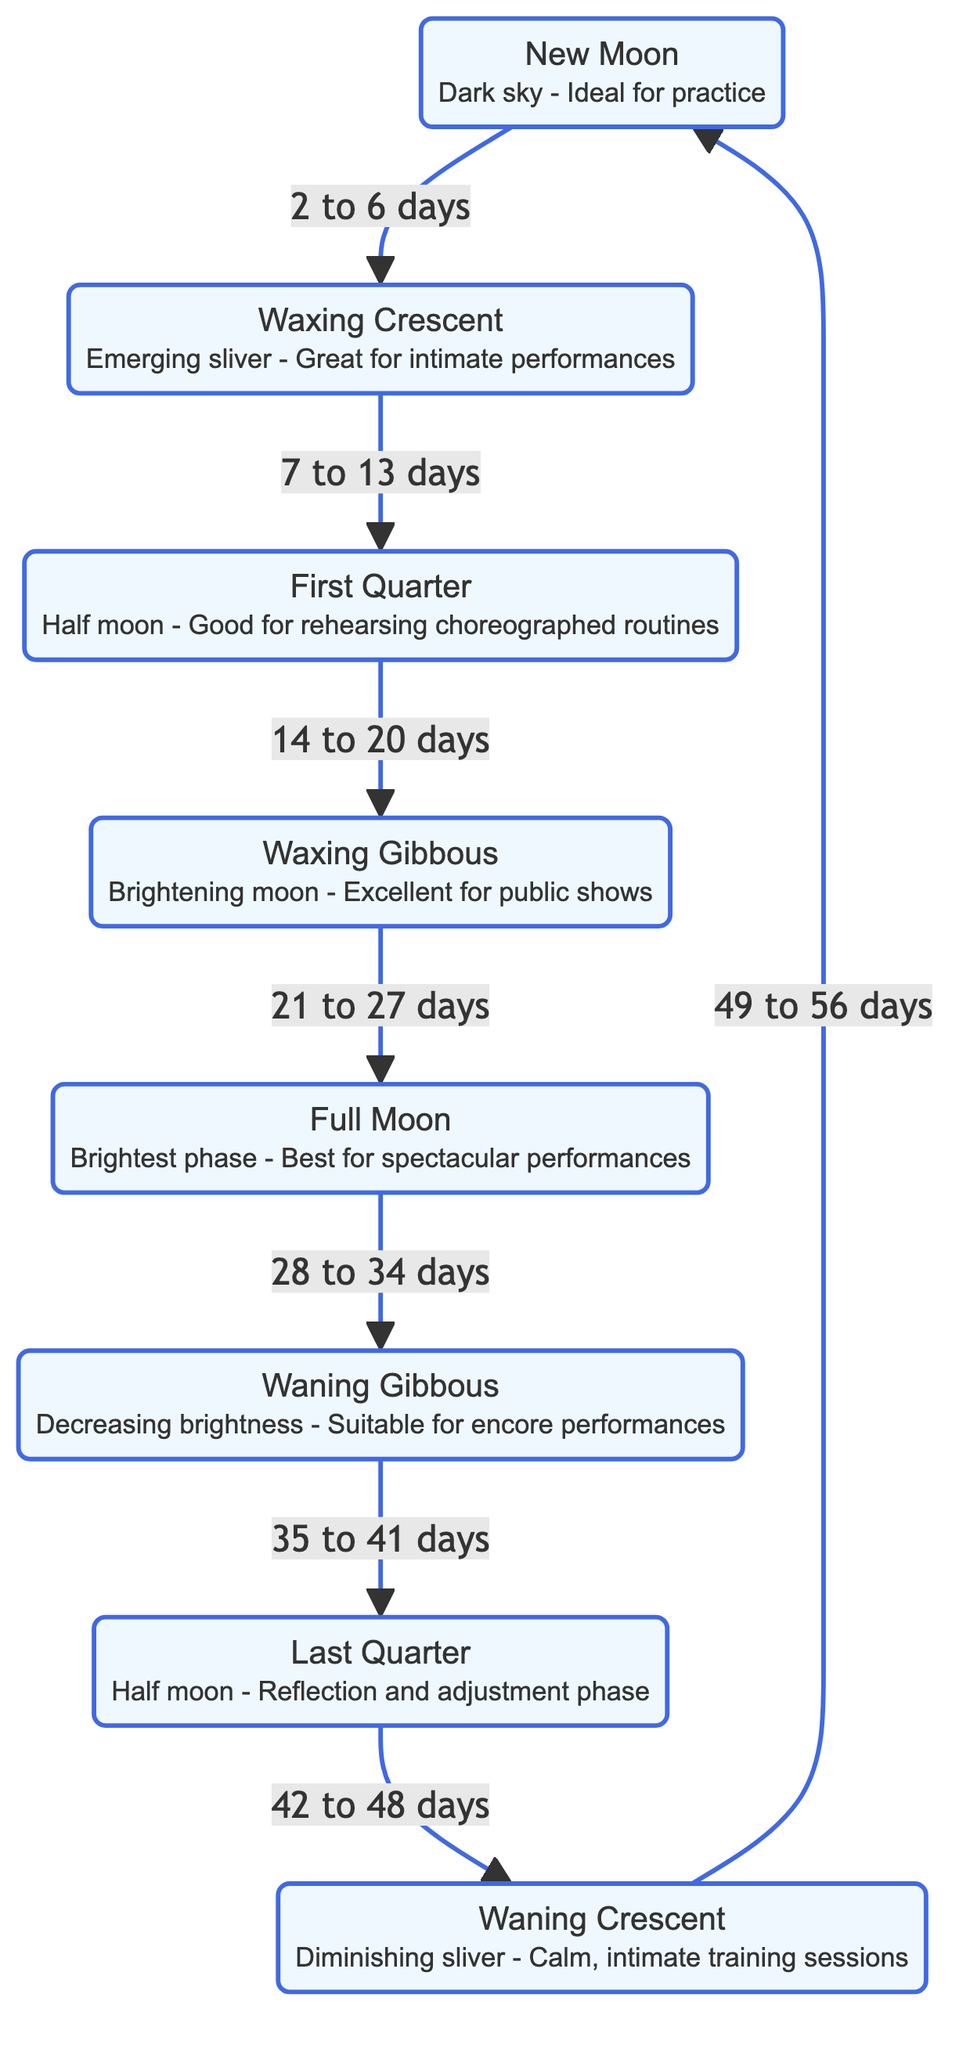What is the first phase of the Moon depicted in the diagram? The diagram indicates that the New Moon is the first phase, which is the starting point of the lunar cycle.
Answer: New Moon How many phases of the Moon are shown in the diagram? The diagram includes a total of eight distinct phases of the Moon displayed in sequential order.
Answer: Eight Which phase follows the Waxing Crescent? By examining the flow from the Waxing Crescent, it connects to the First Quarter as the next phase in the sequence.
Answer: First Quarter What is the optimal performance phase for spectacular performances? The diagram highlights that the Full Moon phase is described as the brightest and best for spectacular performances.
Answer: Full Moon In how many days does the New Moon transition to the Waxing Crescent? The diagram states that the transition from New Moon to Waxing Crescent occurs in a period of 2 to 6 days.
Answer: 2 to 6 days Identify the phase associated with reflection and adjustment. Looking at the phases, the Last Quarter is specifically designated as the time for reflection and adjustments in the routine.
Answer: Last Quarter During which phase is training sessions described as calm and intimate? The diagram notes that during the Waning Crescent phase, training sessions are calm and intimate, making it suitable for practice.
Answer: Waning Crescent What is the sequence of the phases starting from Full Moon to the following phase? By following the diagram's flow, after the Full Moon, the sequence continues to the Waning Gibbous phase.
Answer: Waning Gibbous Which phase offers the best lighting for public shows? According to the description in the diagram, the Waxing Gibbous phase is highlighted as excellent for public shows due to its brightening light.
Answer: Waxing Gibbous 